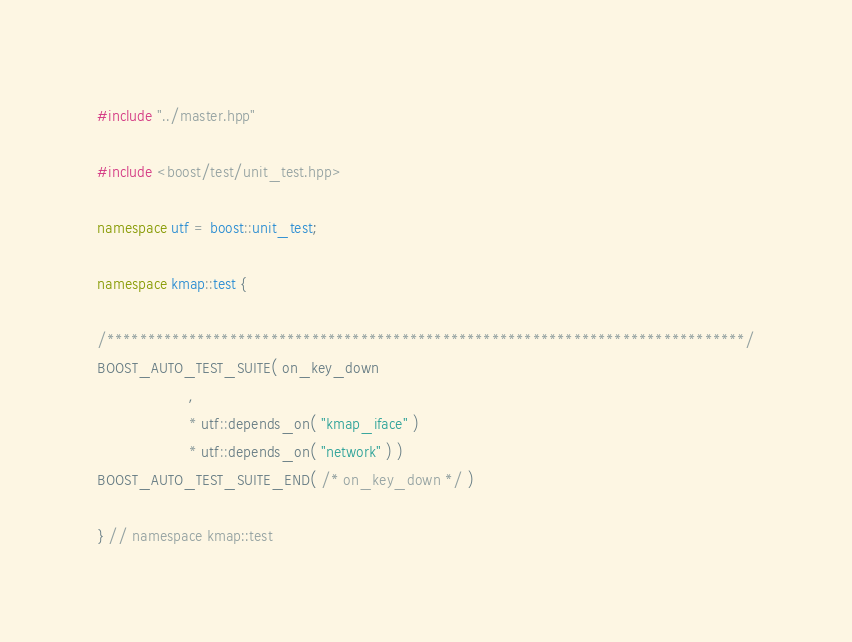<code> <loc_0><loc_0><loc_500><loc_500><_C++_>#include "../master.hpp"

#include <boost/test/unit_test.hpp>

namespace utf = boost::unit_test;

namespace kmap::test {

/******************************************************************************/
BOOST_AUTO_TEST_SUITE( on_key_down 
                     ,
                     * utf::depends_on( "kmap_iface" ) 
                     * utf::depends_on( "network" ) )
BOOST_AUTO_TEST_SUITE_END( /* on_key_down */ )

} // namespace kmap::test</code> 